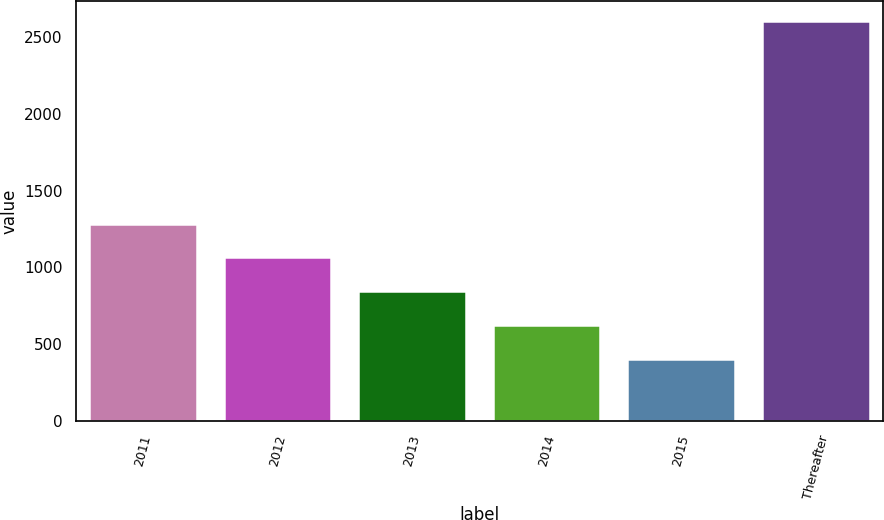Convert chart to OTSL. <chart><loc_0><loc_0><loc_500><loc_500><bar_chart><fcel>2011<fcel>2012<fcel>2013<fcel>2014<fcel>2015<fcel>Thereafter<nl><fcel>1285<fcel>1065<fcel>845<fcel>625<fcel>405<fcel>2605<nl></chart> 